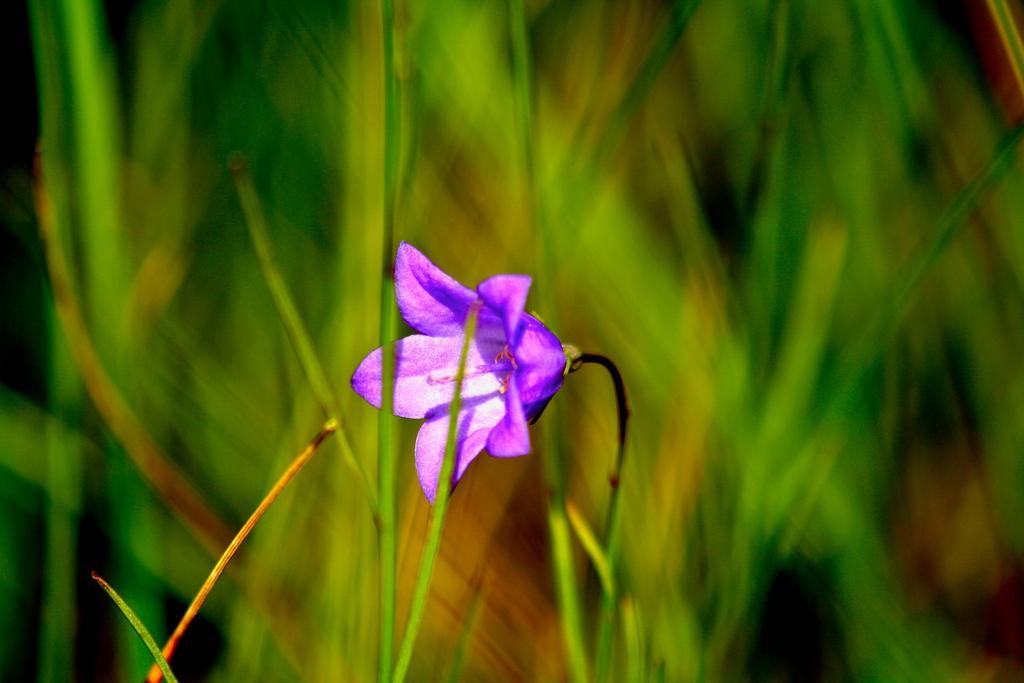Describe this image in one or two sentences. In the middle of the image, there is a plant having violet color flower. And the background is blurred. 